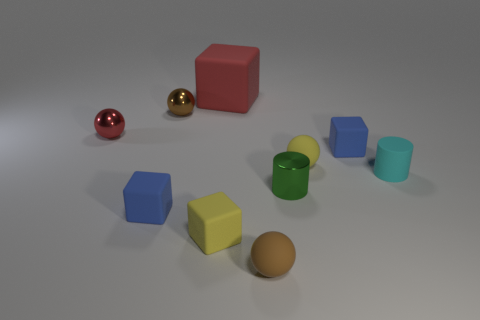Is there any other thing that is the same size as the red matte thing?
Provide a short and direct response. No. There is a small object that is both in front of the red sphere and left of the tiny brown shiny object; what color is it?
Give a very brief answer. Blue. Is the shape of the brown thing to the left of the big rubber block the same as the yellow matte thing that is left of the small green shiny object?
Your answer should be compact. No. There is a brown ball in front of the small green thing; what is it made of?
Provide a succinct answer. Rubber. What size is the other metallic thing that is the same color as the big object?
Your response must be concise. Small. How many things are tiny matte objects left of the metallic cylinder or blue objects?
Provide a succinct answer. 4. Are there the same number of tiny yellow objects that are to the left of the small metallic cylinder and metallic things?
Provide a succinct answer. No. Do the yellow rubber block and the cyan cylinder have the same size?
Make the answer very short. Yes. What color is the other rubber sphere that is the same size as the yellow sphere?
Your response must be concise. Brown. Is the size of the yellow sphere the same as the metallic object in front of the tiny red shiny object?
Provide a short and direct response. Yes. 